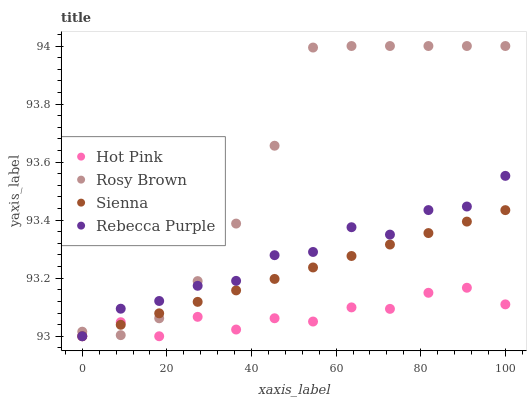Does Hot Pink have the minimum area under the curve?
Answer yes or no. Yes. Does Rosy Brown have the maximum area under the curve?
Answer yes or no. Yes. Does Rosy Brown have the minimum area under the curve?
Answer yes or no. No. Does Hot Pink have the maximum area under the curve?
Answer yes or no. No. Is Sienna the smoothest?
Answer yes or no. Yes. Is Hot Pink the roughest?
Answer yes or no. Yes. Is Rosy Brown the smoothest?
Answer yes or no. No. Is Rosy Brown the roughest?
Answer yes or no. No. Does Sienna have the lowest value?
Answer yes or no. Yes. Does Rosy Brown have the lowest value?
Answer yes or no. No. Does Rosy Brown have the highest value?
Answer yes or no. Yes. Does Hot Pink have the highest value?
Answer yes or no. No. Does Hot Pink intersect Rebecca Purple?
Answer yes or no. Yes. Is Hot Pink less than Rebecca Purple?
Answer yes or no. No. Is Hot Pink greater than Rebecca Purple?
Answer yes or no. No. 